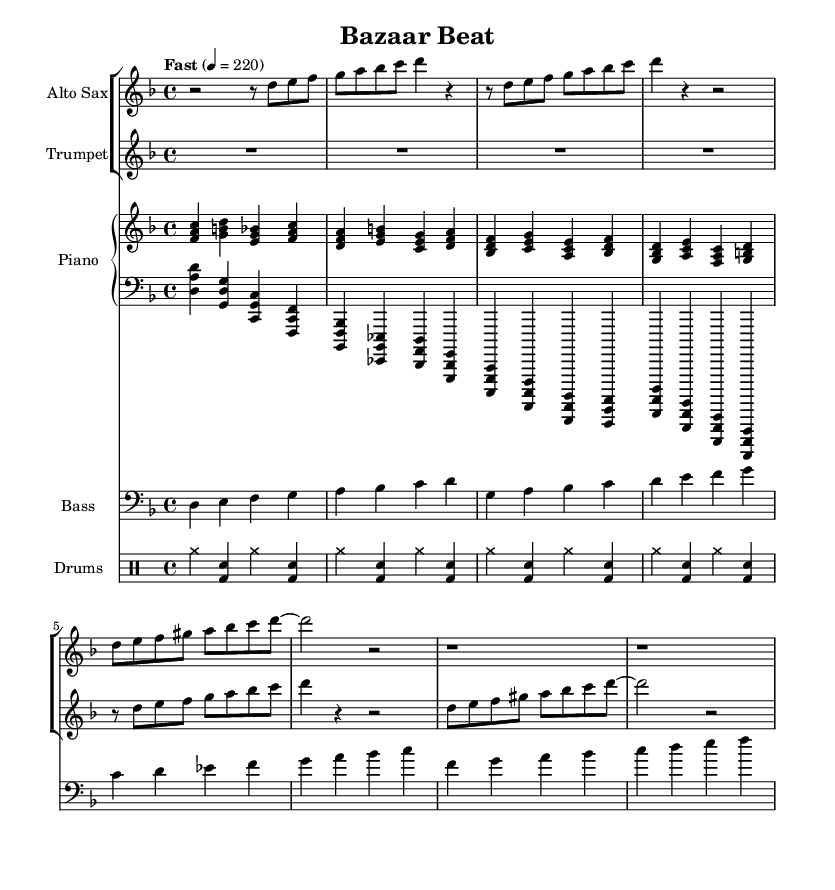What is the key signature of this music? The key signature indicates D minor, which has one flat, B flat, shown at the beginning of the staff.
Answer: D minor What is the time signature of this music? The time signature is indicated as 4/4, which means there are four beats in each measure and a quarter note gets one beat.
Answer: 4/4 What is the tempo marking indicated in this sheet music? The tempo marking states "Fast" with a metronome marking of 220, suggesting a fast-paced performance.
Answer: Fast How many measures does the saxophone music contain? Counting the measures in the saxophone staff shows there are eight measures in total.
Answer: Eight measures What is the highest note played by the trumpet? The highest note in the trumpet music is C, which is found in the melody line.
Answer: C How many different instruments are included in this score? There are five different instruments: Alto Sax, Trumpet, Piano (with two staves), Bass, and Drums.
Answer: Five instruments What style of music does this piece exemplify? The piece exemplifies bebop jazz, characterized by its fast tempos and complex melodies reflecting urban life.
Answer: Bebop jazz 